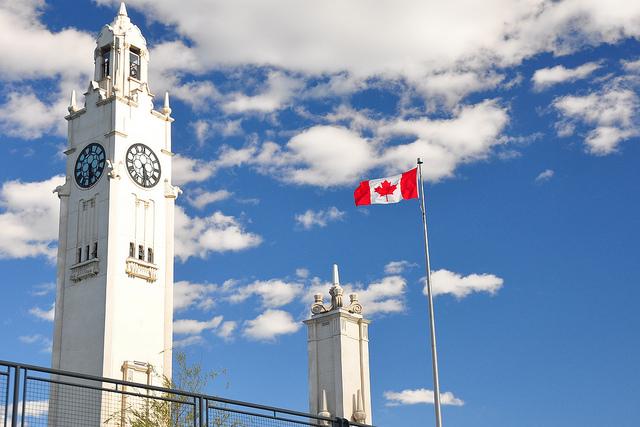What time is it?
Short answer required. 5:30. Is it raining?
Keep it brief. No. What country's flag is shown?
Write a very short answer. Canada. What time does the clock read?
Keep it brief. 5:30. 